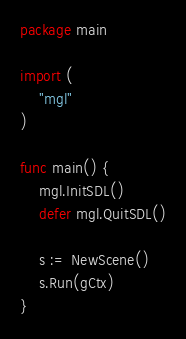Convert code to text. <code><loc_0><loc_0><loc_500><loc_500><_Go_>package main

import (
	"mgl"
)

func main() {
	mgl.InitSDL()
	defer mgl.QuitSDL()

	s := NewScene()
	s.Run(gCtx)
}
</code> 